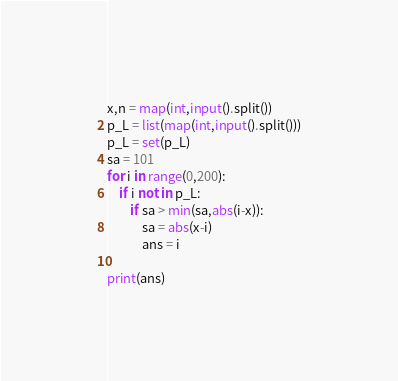Convert code to text. <code><loc_0><loc_0><loc_500><loc_500><_Python_>x,n = map(int,input().split())
p_L = list(map(int,input().split()))
p_L = set(p_L)
sa = 101
for i in range(0,200):
    if i not in p_L:
        if sa > min(sa,abs(i-x)):
            sa = abs(x-i)
            ans = i

print(ans)</code> 